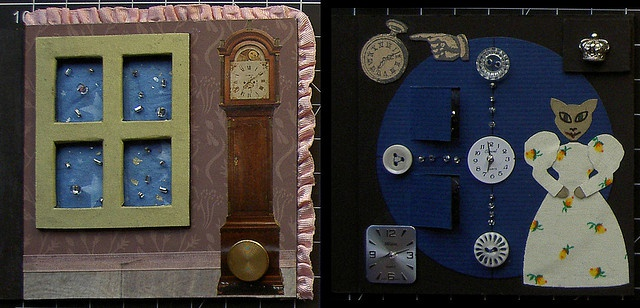Describe the objects in this image and their specific colors. I can see clock in black and gray tones, clock in black, darkgray, gray, and lightgray tones, clock in black, tan, gray, and olive tones, clock in black and gray tones, and clock in black, gray, darkgray, and navy tones in this image. 